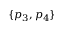<formula> <loc_0><loc_0><loc_500><loc_500>\{ p _ { 3 } , p _ { 4 } \}</formula> 